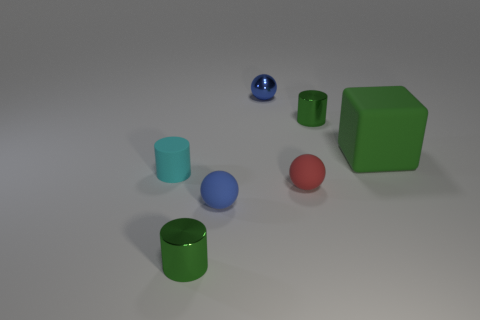Can you tell me how the lighting in this scene affects the appearance of the objects? The lighting in this scene is soft and diffused, casting gentle shadows on the right side of the objects, which helps to enhance the three-dimensional form of each one. There is no harsh glare, which allows the true colors of the objects to remain vibrant and distinct. 